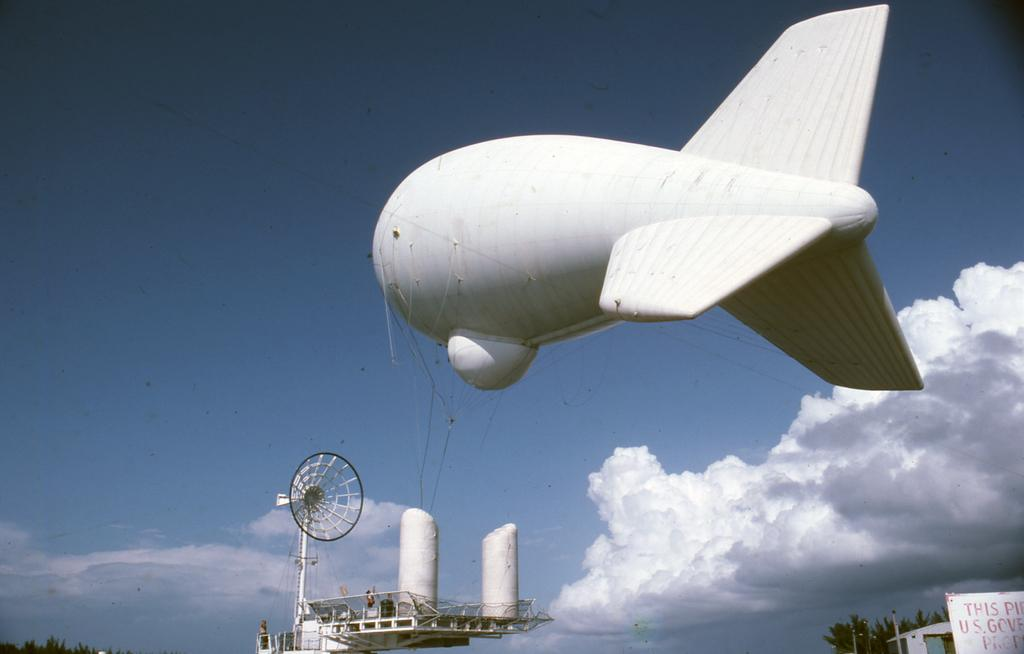What structure can be seen in the image? There is an antenna in the image. What type of geographical feature is present in the image? There are tunnels in the image. What is floating in the sky in the image? There is an air balloon in the sky, and it has the shape of an airplane. What can be seen in the sky besides the air balloon? There are clouds in the sky. Where is the swing located in the image? There is no swing present in the image. What type of sign can be seen in the image? There is no sign present in the image. 